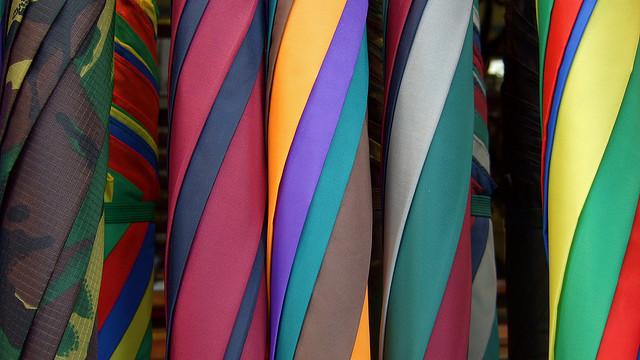Do these match?
Be succinct. No. What are these?
Answer briefly. Umbrellas. What color is predominant?
Short answer required. Blue. 